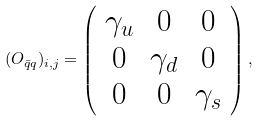Convert formula to latex. <formula><loc_0><loc_0><loc_500><loc_500>( O _ { \bar { q } q } ) _ { i , j } = \left ( \begin{array} { c c c } \gamma _ { u } & 0 & 0 \\ 0 & \gamma _ { d } & 0 \\ 0 & 0 & \gamma _ { s } \end{array} \right ) ,</formula> 